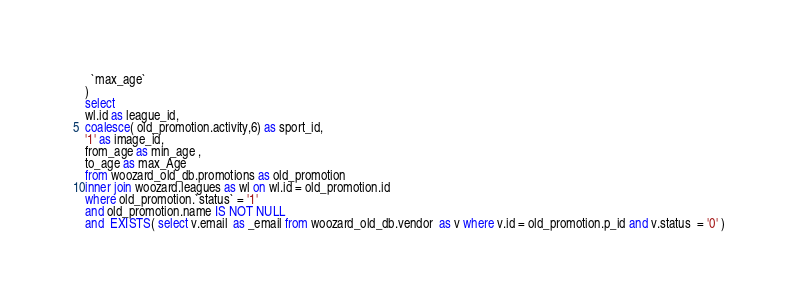<code> <loc_0><loc_0><loc_500><loc_500><_SQL_>  `max_age`
)
select 
wl.id as league_id,
coalesce( old_promotion.activity,6) as sport_id,
'1' as image_id,
from_age as min_age ,
to_age as max_Age 
from woozard_old_db.promotions as old_promotion
inner join woozard.leagues as wl on wl.id = old_promotion.id
where old_promotion.`status` = '1'
and old_promotion.name IS NOT NULL
and  EXISTS( select v.email  as _email from woozard_old_db.vendor  as v where v.id = old_promotion.p_id and v.status  = '0' )</code> 